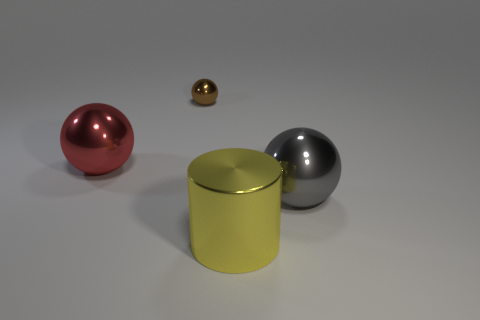Does the large ball to the right of the big red metal sphere have the same material as the red ball that is in front of the brown ball?
Offer a very short reply. Yes. There is a gray object that is the same size as the red metallic sphere; what is its shape?
Your response must be concise. Sphere. How many other things are the same color as the large cylinder?
Make the answer very short. 0. How many yellow things are either shiny cylinders or metallic things?
Keep it short and to the point. 1. There is a big metal object that is right of the yellow object; does it have the same shape as the big object that is on the left side of the brown object?
Your response must be concise. Yes. How many other objects are there of the same material as the red thing?
Your answer should be very brief. 3. There is a large yellow metallic cylinder that is on the left side of the big shiny ball that is in front of the large red metallic object; is there a gray thing that is right of it?
Ensure brevity in your answer.  Yes. Is the material of the gray object the same as the red ball?
Make the answer very short. Yes. Is there anything else that is the same shape as the red shiny object?
Provide a succinct answer. Yes. The big gray ball in front of the shiny object behind the red thing is made of what material?
Give a very brief answer. Metal. 